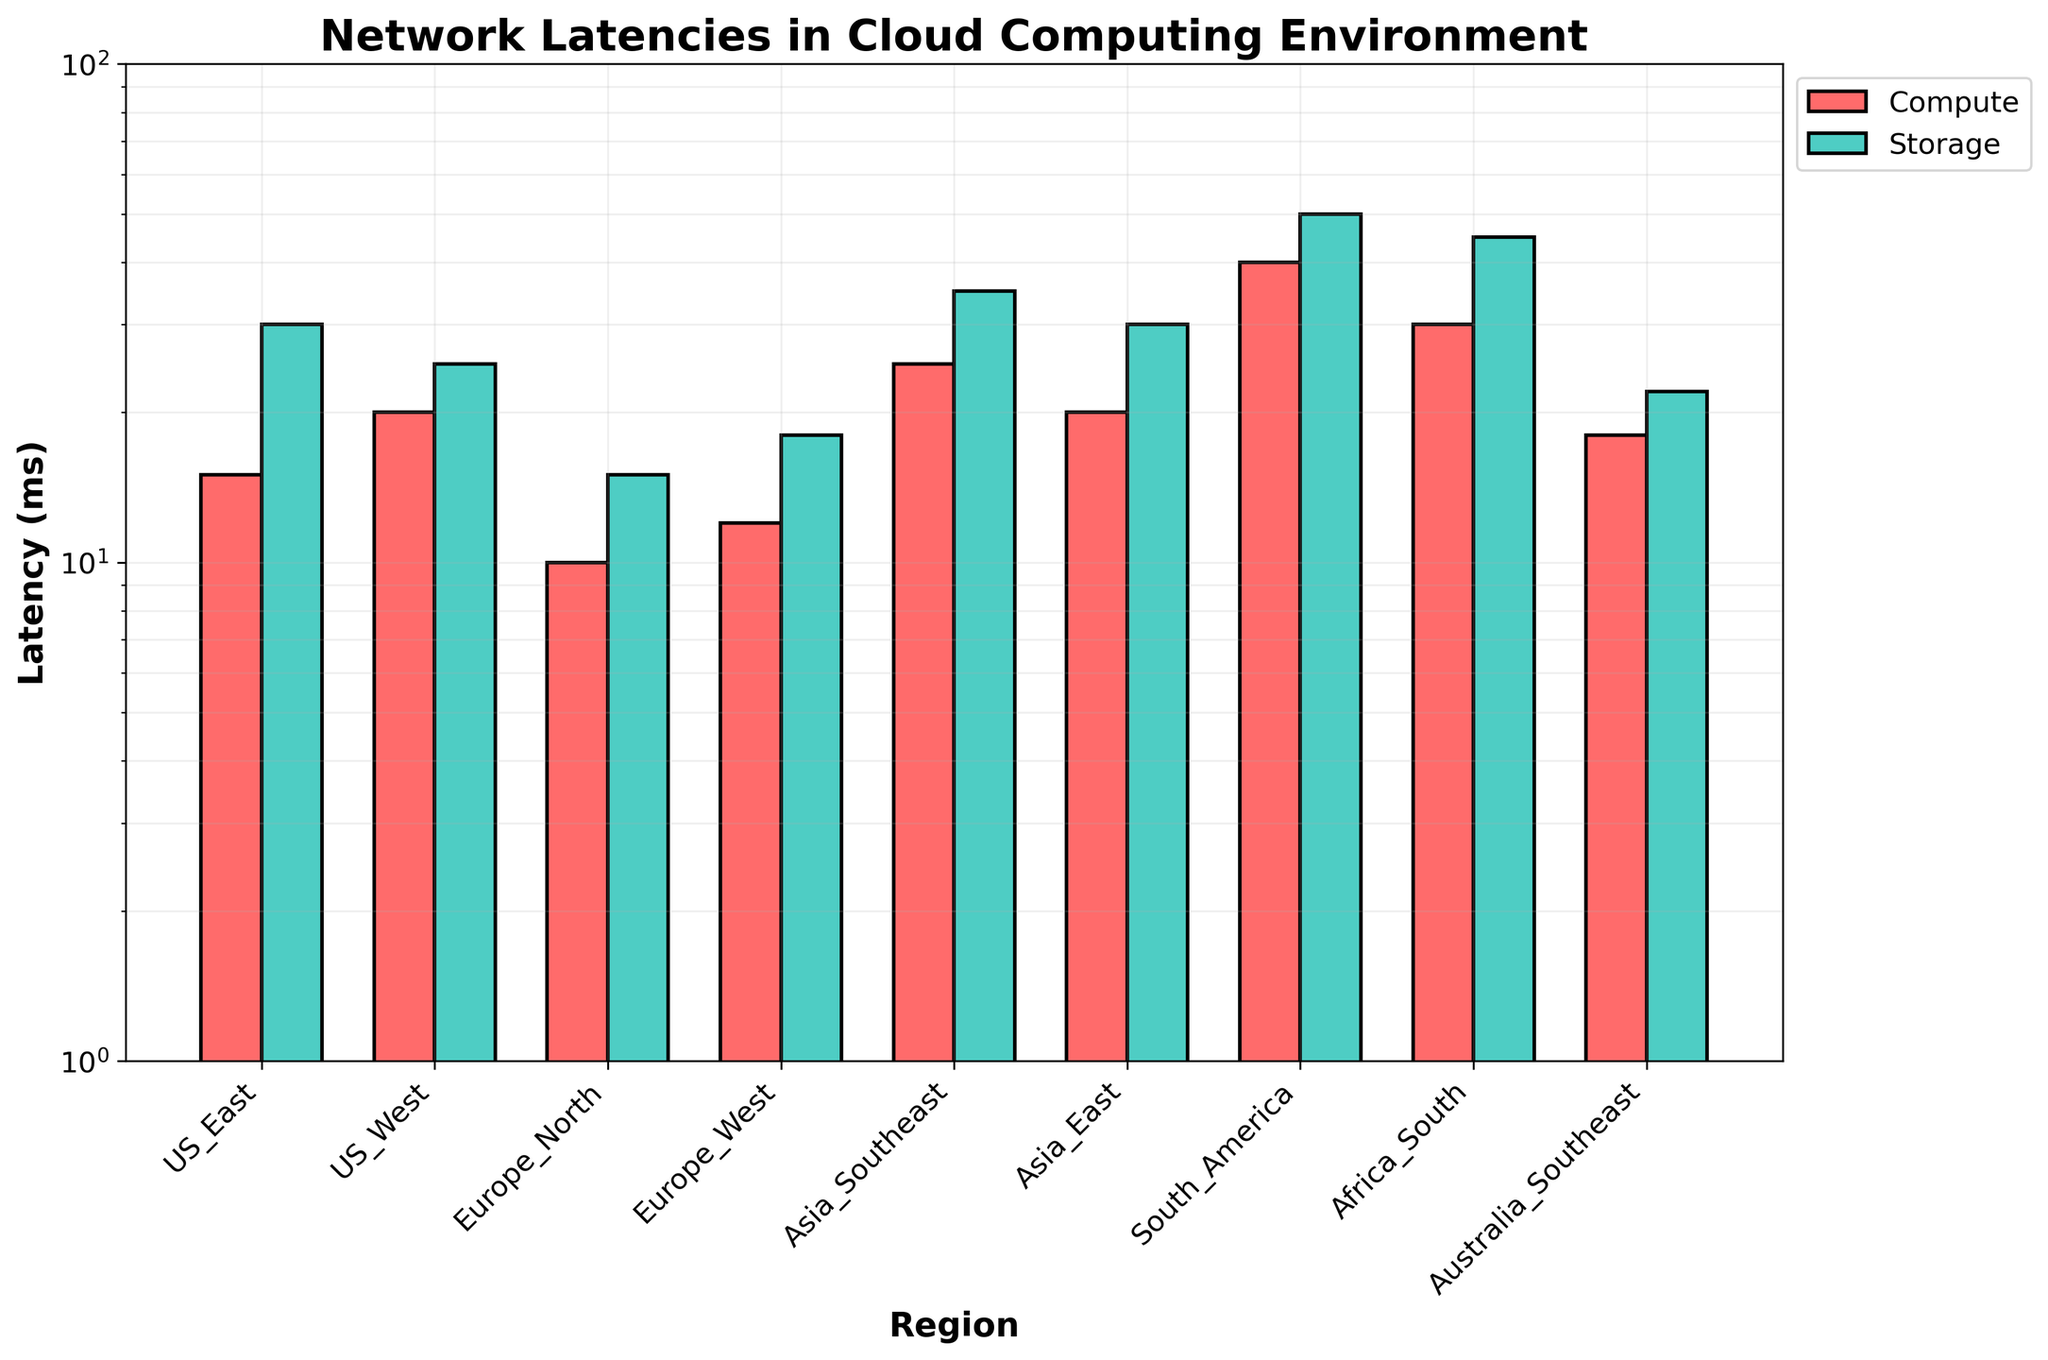What is the title of the figure? The title is provided at the top of the figure in a bold font which clearly states the context of the graph.
Answer: Network Latencies in Cloud Computing Environment What is the unit of measurement on the y-axis? The label of the y-axis, written vertically, indicates the unit of measurement.
Answer: ms (milliseconds) How many regions are represented in the figure? By counting the x-ticks (labels on the x-axis) corresponding to each region, we can determine the number of regions.
Answer: 9 What color represents the Compute service latencies? The color of the bars for Compute service is visibly distinct from the Storage service.
Answer: Red (or #FF6B6B) What region has the highest latency for the Storage service, and what is the latency value? By comparing the height of the bars color-coded for Storage, locate the highest bar and check its data point.
Answer: South America, 50 ms Which region has the lowest latency for the Compute service? Identify the shortest bar among those color-coded for the Compute service and note the associated region.
Answer: Europe North How many bars in total are plotted in the figure? Count the total number of bars, considering each region has two bars representing Compute and Storage services.
Answer: 18 bars 